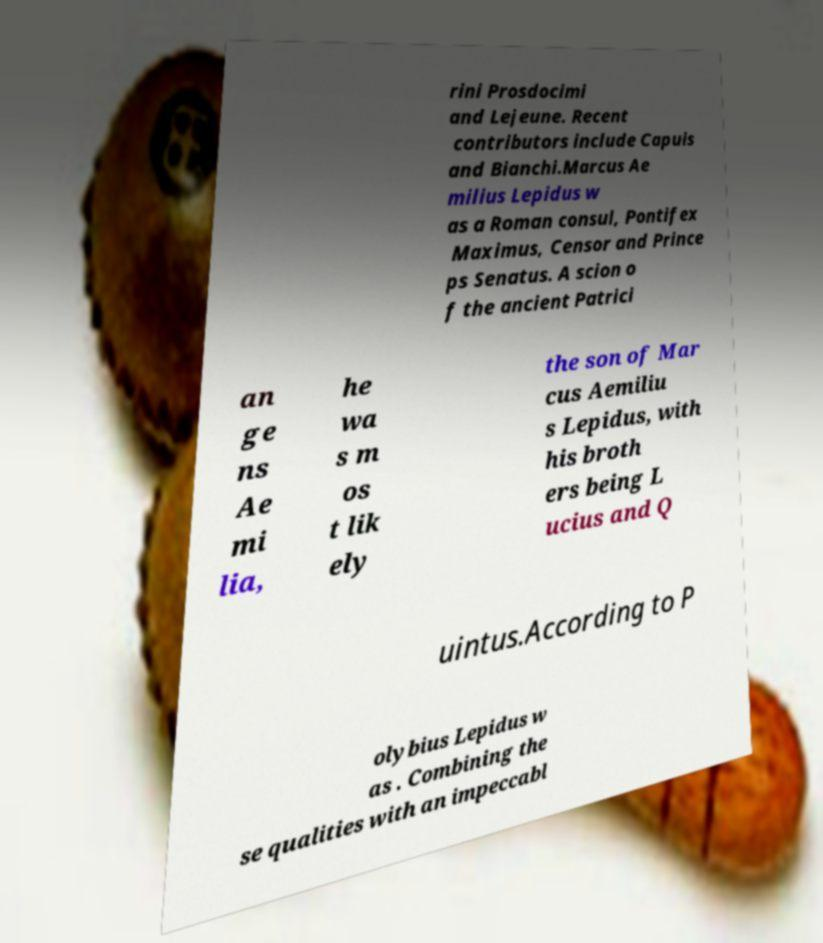There's text embedded in this image that I need extracted. Can you transcribe it verbatim? rini Prosdocimi and Lejeune. Recent contributors include Capuis and Bianchi.Marcus Ae milius Lepidus w as a Roman consul, Pontifex Maximus, Censor and Prince ps Senatus. A scion o f the ancient Patrici an ge ns Ae mi lia, he wa s m os t lik ely the son of Mar cus Aemiliu s Lepidus, with his broth ers being L ucius and Q uintus.According to P olybius Lepidus w as . Combining the se qualities with an impeccabl 